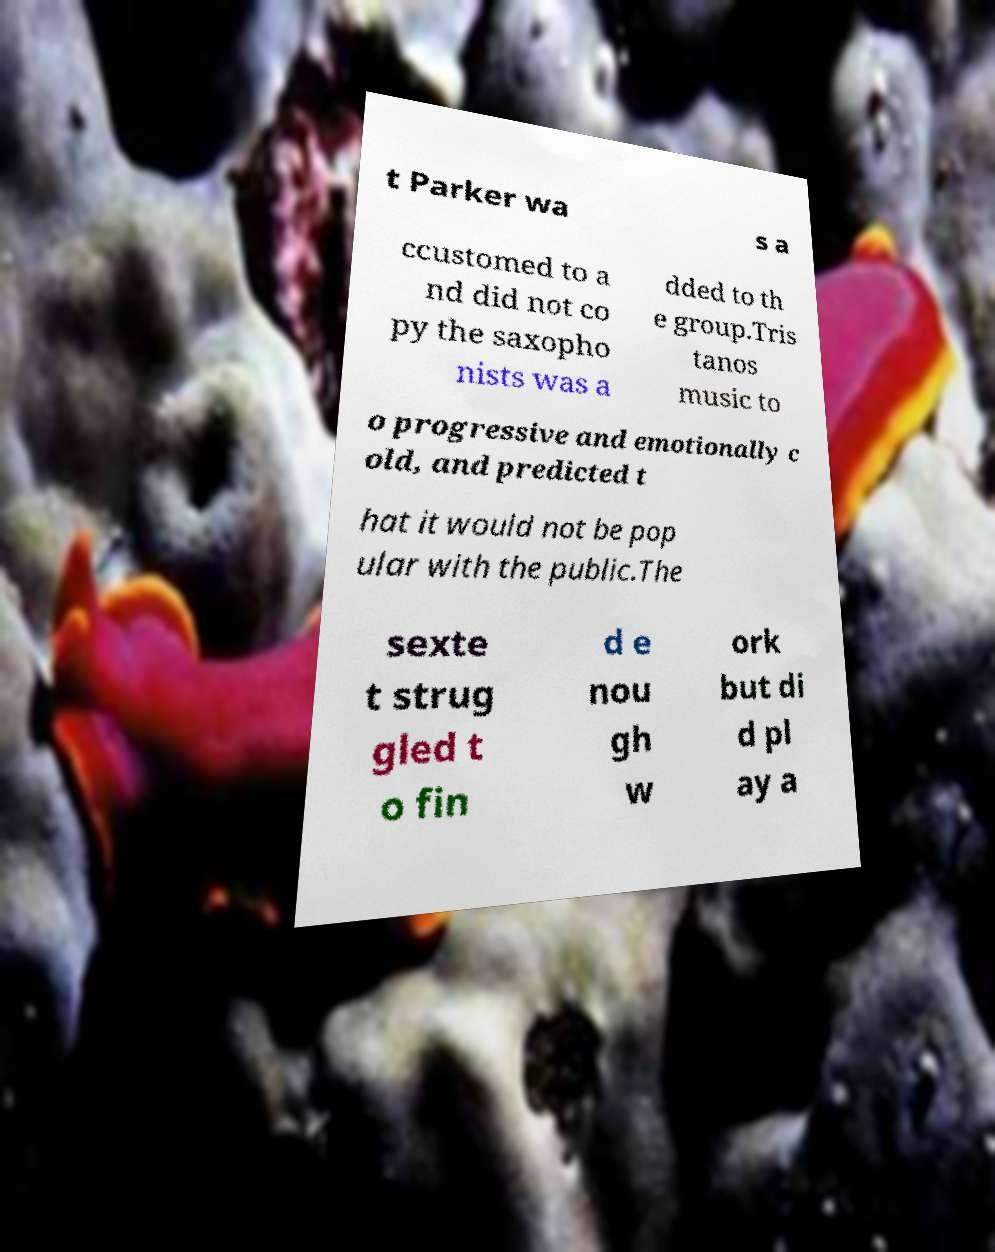Please identify and transcribe the text found in this image. t Parker wa s a ccustomed to a nd did not co py the saxopho nists was a dded to th e group.Tris tanos music to o progressive and emotionally c old, and predicted t hat it would not be pop ular with the public.The sexte t strug gled t o fin d e nou gh w ork but di d pl ay a 